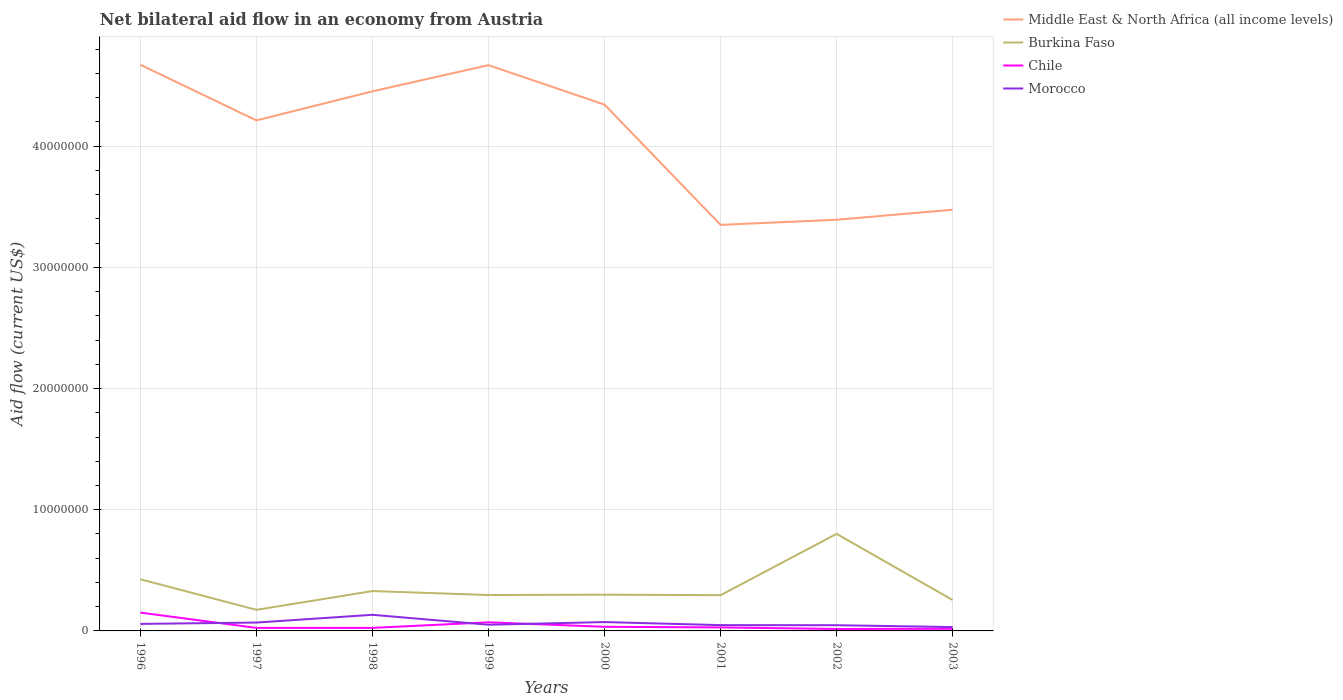Does the line corresponding to Middle East & North Africa (all income levels) intersect with the line corresponding to Chile?
Your answer should be compact. No. In which year was the net bilateral aid flow in Morocco maximum?
Your response must be concise. 2003. What is the difference between the highest and the second highest net bilateral aid flow in Middle East & North Africa (all income levels)?
Keep it short and to the point. 1.32e+07. What is the difference between the highest and the lowest net bilateral aid flow in Chile?
Keep it short and to the point. 2. How many lines are there?
Ensure brevity in your answer.  4. What is the difference between two consecutive major ticks on the Y-axis?
Provide a succinct answer. 1.00e+07. Where does the legend appear in the graph?
Keep it short and to the point. Top right. How many legend labels are there?
Keep it short and to the point. 4. How are the legend labels stacked?
Your answer should be compact. Vertical. What is the title of the graph?
Provide a succinct answer. Net bilateral aid flow in an economy from Austria. What is the Aid flow (current US$) of Middle East & North Africa (all income levels) in 1996?
Your response must be concise. 4.67e+07. What is the Aid flow (current US$) of Burkina Faso in 1996?
Keep it short and to the point. 4.26e+06. What is the Aid flow (current US$) in Chile in 1996?
Make the answer very short. 1.51e+06. What is the Aid flow (current US$) of Morocco in 1996?
Keep it short and to the point. 5.80e+05. What is the Aid flow (current US$) in Middle East & North Africa (all income levels) in 1997?
Provide a short and direct response. 4.21e+07. What is the Aid flow (current US$) in Burkina Faso in 1997?
Make the answer very short. 1.74e+06. What is the Aid flow (current US$) in Chile in 1997?
Offer a very short reply. 2.50e+05. What is the Aid flow (current US$) of Morocco in 1997?
Your response must be concise. 6.90e+05. What is the Aid flow (current US$) of Middle East & North Africa (all income levels) in 1998?
Provide a short and direct response. 4.45e+07. What is the Aid flow (current US$) of Burkina Faso in 1998?
Your answer should be very brief. 3.29e+06. What is the Aid flow (current US$) of Chile in 1998?
Your answer should be compact. 2.50e+05. What is the Aid flow (current US$) of Morocco in 1998?
Your response must be concise. 1.33e+06. What is the Aid flow (current US$) of Middle East & North Africa (all income levels) in 1999?
Keep it short and to the point. 4.67e+07. What is the Aid flow (current US$) of Burkina Faso in 1999?
Keep it short and to the point. 2.96e+06. What is the Aid flow (current US$) in Chile in 1999?
Keep it short and to the point. 7.10e+05. What is the Aid flow (current US$) in Morocco in 1999?
Your answer should be compact. 5.10e+05. What is the Aid flow (current US$) in Middle East & North Africa (all income levels) in 2000?
Provide a succinct answer. 4.34e+07. What is the Aid flow (current US$) in Burkina Faso in 2000?
Offer a terse response. 2.99e+06. What is the Aid flow (current US$) in Chile in 2000?
Provide a succinct answer. 3.40e+05. What is the Aid flow (current US$) in Morocco in 2000?
Offer a terse response. 7.30e+05. What is the Aid flow (current US$) of Middle East & North Africa (all income levels) in 2001?
Give a very brief answer. 3.35e+07. What is the Aid flow (current US$) in Burkina Faso in 2001?
Your response must be concise. 2.95e+06. What is the Aid flow (current US$) in Middle East & North Africa (all income levels) in 2002?
Your answer should be very brief. 3.39e+07. What is the Aid flow (current US$) in Burkina Faso in 2002?
Offer a terse response. 8.01e+06. What is the Aid flow (current US$) of Chile in 2002?
Ensure brevity in your answer.  1.60e+05. What is the Aid flow (current US$) in Morocco in 2002?
Keep it short and to the point. 4.70e+05. What is the Aid flow (current US$) of Middle East & North Africa (all income levels) in 2003?
Give a very brief answer. 3.48e+07. What is the Aid flow (current US$) in Burkina Faso in 2003?
Your answer should be compact. 2.55e+06. Across all years, what is the maximum Aid flow (current US$) in Middle East & North Africa (all income levels)?
Keep it short and to the point. 4.67e+07. Across all years, what is the maximum Aid flow (current US$) in Burkina Faso?
Your answer should be compact. 8.01e+06. Across all years, what is the maximum Aid flow (current US$) of Chile?
Provide a short and direct response. 1.51e+06. Across all years, what is the maximum Aid flow (current US$) in Morocco?
Offer a terse response. 1.33e+06. Across all years, what is the minimum Aid flow (current US$) of Middle East & North Africa (all income levels)?
Ensure brevity in your answer.  3.35e+07. Across all years, what is the minimum Aid flow (current US$) in Burkina Faso?
Your answer should be very brief. 1.74e+06. What is the total Aid flow (current US$) in Middle East & North Africa (all income levels) in the graph?
Your answer should be very brief. 3.26e+08. What is the total Aid flow (current US$) of Burkina Faso in the graph?
Your response must be concise. 2.88e+07. What is the total Aid flow (current US$) of Chile in the graph?
Offer a terse response. 3.69e+06. What is the total Aid flow (current US$) in Morocco in the graph?
Provide a short and direct response. 5.11e+06. What is the difference between the Aid flow (current US$) in Middle East & North Africa (all income levels) in 1996 and that in 1997?
Provide a succinct answer. 4.59e+06. What is the difference between the Aid flow (current US$) of Burkina Faso in 1996 and that in 1997?
Provide a short and direct response. 2.52e+06. What is the difference between the Aid flow (current US$) in Chile in 1996 and that in 1997?
Offer a terse response. 1.26e+06. What is the difference between the Aid flow (current US$) of Middle East & North Africa (all income levels) in 1996 and that in 1998?
Offer a very short reply. 2.19e+06. What is the difference between the Aid flow (current US$) of Burkina Faso in 1996 and that in 1998?
Offer a terse response. 9.70e+05. What is the difference between the Aid flow (current US$) of Chile in 1996 and that in 1998?
Your answer should be very brief. 1.26e+06. What is the difference between the Aid flow (current US$) in Morocco in 1996 and that in 1998?
Offer a terse response. -7.50e+05. What is the difference between the Aid flow (current US$) in Middle East & North Africa (all income levels) in 1996 and that in 1999?
Your answer should be compact. 3.00e+04. What is the difference between the Aid flow (current US$) of Burkina Faso in 1996 and that in 1999?
Make the answer very short. 1.30e+06. What is the difference between the Aid flow (current US$) in Middle East & North Africa (all income levels) in 1996 and that in 2000?
Your answer should be very brief. 3.29e+06. What is the difference between the Aid flow (current US$) of Burkina Faso in 1996 and that in 2000?
Your answer should be very brief. 1.27e+06. What is the difference between the Aid flow (current US$) in Chile in 1996 and that in 2000?
Provide a short and direct response. 1.17e+06. What is the difference between the Aid flow (current US$) in Middle East & North Africa (all income levels) in 1996 and that in 2001?
Offer a terse response. 1.32e+07. What is the difference between the Aid flow (current US$) of Burkina Faso in 1996 and that in 2001?
Offer a very short reply. 1.31e+06. What is the difference between the Aid flow (current US$) of Chile in 1996 and that in 2001?
Give a very brief answer. 1.22e+06. What is the difference between the Aid flow (current US$) in Middle East & North Africa (all income levels) in 1996 and that in 2002?
Your answer should be very brief. 1.28e+07. What is the difference between the Aid flow (current US$) in Burkina Faso in 1996 and that in 2002?
Keep it short and to the point. -3.75e+06. What is the difference between the Aid flow (current US$) of Chile in 1996 and that in 2002?
Give a very brief answer. 1.35e+06. What is the difference between the Aid flow (current US$) in Middle East & North Africa (all income levels) in 1996 and that in 2003?
Provide a short and direct response. 1.20e+07. What is the difference between the Aid flow (current US$) in Burkina Faso in 1996 and that in 2003?
Offer a terse response. 1.71e+06. What is the difference between the Aid flow (current US$) in Chile in 1996 and that in 2003?
Offer a terse response. 1.33e+06. What is the difference between the Aid flow (current US$) of Morocco in 1996 and that in 2003?
Offer a terse response. 2.60e+05. What is the difference between the Aid flow (current US$) in Middle East & North Africa (all income levels) in 1997 and that in 1998?
Keep it short and to the point. -2.40e+06. What is the difference between the Aid flow (current US$) in Burkina Faso in 1997 and that in 1998?
Ensure brevity in your answer.  -1.55e+06. What is the difference between the Aid flow (current US$) in Morocco in 1997 and that in 1998?
Keep it short and to the point. -6.40e+05. What is the difference between the Aid flow (current US$) in Middle East & North Africa (all income levels) in 1997 and that in 1999?
Provide a short and direct response. -4.56e+06. What is the difference between the Aid flow (current US$) of Burkina Faso in 1997 and that in 1999?
Your response must be concise. -1.22e+06. What is the difference between the Aid flow (current US$) in Chile in 1997 and that in 1999?
Your response must be concise. -4.60e+05. What is the difference between the Aid flow (current US$) of Morocco in 1997 and that in 1999?
Give a very brief answer. 1.80e+05. What is the difference between the Aid flow (current US$) of Middle East & North Africa (all income levels) in 1997 and that in 2000?
Give a very brief answer. -1.30e+06. What is the difference between the Aid flow (current US$) in Burkina Faso in 1997 and that in 2000?
Ensure brevity in your answer.  -1.25e+06. What is the difference between the Aid flow (current US$) in Middle East & North Africa (all income levels) in 1997 and that in 2001?
Ensure brevity in your answer.  8.62e+06. What is the difference between the Aid flow (current US$) in Burkina Faso in 1997 and that in 2001?
Make the answer very short. -1.21e+06. What is the difference between the Aid flow (current US$) of Middle East & North Africa (all income levels) in 1997 and that in 2002?
Keep it short and to the point. 8.20e+06. What is the difference between the Aid flow (current US$) in Burkina Faso in 1997 and that in 2002?
Provide a succinct answer. -6.27e+06. What is the difference between the Aid flow (current US$) of Morocco in 1997 and that in 2002?
Your response must be concise. 2.20e+05. What is the difference between the Aid flow (current US$) in Middle East & North Africa (all income levels) in 1997 and that in 2003?
Make the answer very short. 7.37e+06. What is the difference between the Aid flow (current US$) in Burkina Faso in 1997 and that in 2003?
Make the answer very short. -8.10e+05. What is the difference between the Aid flow (current US$) of Middle East & North Africa (all income levels) in 1998 and that in 1999?
Offer a very short reply. -2.16e+06. What is the difference between the Aid flow (current US$) of Chile in 1998 and that in 1999?
Provide a short and direct response. -4.60e+05. What is the difference between the Aid flow (current US$) of Morocco in 1998 and that in 1999?
Your answer should be very brief. 8.20e+05. What is the difference between the Aid flow (current US$) of Middle East & North Africa (all income levels) in 1998 and that in 2000?
Ensure brevity in your answer.  1.10e+06. What is the difference between the Aid flow (current US$) of Burkina Faso in 1998 and that in 2000?
Your answer should be compact. 3.00e+05. What is the difference between the Aid flow (current US$) in Morocco in 1998 and that in 2000?
Provide a short and direct response. 6.00e+05. What is the difference between the Aid flow (current US$) in Middle East & North Africa (all income levels) in 1998 and that in 2001?
Your answer should be very brief. 1.10e+07. What is the difference between the Aid flow (current US$) of Burkina Faso in 1998 and that in 2001?
Offer a terse response. 3.40e+05. What is the difference between the Aid flow (current US$) of Morocco in 1998 and that in 2001?
Offer a terse response. 8.50e+05. What is the difference between the Aid flow (current US$) of Middle East & North Africa (all income levels) in 1998 and that in 2002?
Offer a very short reply. 1.06e+07. What is the difference between the Aid flow (current US$) in Burkina Faso in 1998 and that in 2002?
Make the answer very short. -4.72e+06. What is the difference between the Aid flow (current US$) in Morocco in 1998 and that in 2002?
Make the answer very short. 8.60e+05. What is the difference between the Aid flow (current US$) in Middle East & North Africa (all income levels) in 1998 and that in 2003?
Make the answer very short. 9.77e+06. What is the difference between the Aid flow (current US$) in Burkina Faso in 1998 and that in 2003?
Provide a short and direct response. 7.40e+05. What is the difference between the Aid flow (current US$) of Chile in 1998 and that in 2003?
Make the answer very short. 7.00e+04. What is the difference between the Aid flow (current US$) in Morocco in 1998 and that in 2003?
Your answer should be very brief. 1.01e+06. What is the difference between the Aid flow (current US$) of Middle East & North Africa (all income levels) in 1999 and that in 2000?
Offer a terse response. 3.26e+06. What is the difference between the Aid flow (current US$) in Chile in 1999 and that in 2000?
Provide a short and direct response. 3.70e+05. What is the difference between the Aid flow (current US$) in Morocco in 1999 and that in 2000?
Provide a succinct answer. -2.20e+05. What is the difference between the Aid flow (current US$) in Middle East & North Africa (all income levels) in 1999 and that in 2001?
Offer a terse response. 1.32e+07. What is the difference between the Aid flow (current US$) in Morocco in 1999 and that in 2001?
Your response must be concise. 3.00e+04. What is the difference between the Aid flow (current US$) in Middle East & North Africa (all income levels) in 1999 and that in 2002?
Offer a very short reply. 1.28e+07. What is the difference between the Aid flow (current US$) in Burkina Faso in 1999 and that in 2002?
Provide a succinct answer. -5.05e+06. What is the difference between the Aid flow (current US$) of Chile in 1999 and that in 2002?
Make the answer very short. 5.50e+05. What is the difference between the Aid flow (current US$) of Morocco in 1999 and that in 2002?
Ensure brevity in your answer.  4.00e+04. What is the difference between the Aid flow (current US$) in Middle East & North Africa (all income levels) in 1999 and that in 2003?
Offer a very short reply. 1.19e+07. What is the difference between the Aid flow (current US$) of Burkina Faso in 1999 and that in 2003?
Make the answer very short. 4.10e+05. What is the difference between the Aid flow (current US$) in Chile in 1999 and that in 2003?
Your answer should be compact. 5.30e+05. What is the difference between the Aid flow (current US$) of Middle East & North Africa (all income levels) in 2000 and that in 2001?
Offer a terse response. 9.92e+06. What is the difference between the Aid flow (current US$) in Chile in 2000 and that in 2001?
Make the answer very short. 5.00e+04. What is the difference between the Aid flow (current US$) of Middle East & North Africa (all income levels) in 2000 and that in 2002?
Your answer should be compact. 9.50e+06. What is the difference between the Aid flow (current US$) in Burkina Faso in 2000 and that in 2002?
Offer a terse response. -5.02e+06. What is the difference between the Aid flow (current US$) of Middle East & North Africa (all income levels) in 2000 and that in 2003?
Your answer should be very brief. 8.67e+06. What is the difference between the Aid flow (current US$) of Burkina Faso in 2000 and that in 2003?
Make the answer very short. 4.40e+05. What is the difference between the Aid flow (current US$) of Chile in 2000 and that in 2003?
Make the answer very short. 1.60e+05. What is the difference between the Aid flow (current US$) in Morocco in 2000 and that in 2003?
Provide a short and direct response. 4.10e+05. What is the difference between the Aid flow (current US$) of Middle East & North Africa (all income levels) in 2001 and that in 2002?
Your answer should be compact. -4.20e+05. What is the difference between the Aid flow (current US$) of Burkina Faso in 2001 and that in 2002?
Your answer should be very brief. -5.06e+06. What is the difference between the Aid flow (current US$) in Chile in 2001 and that in 2002?
Offer a terse response. 1.30e+05. What is the difference between the Aid flow (current US$) in Middle East & North Africa (all income levels) in 2001 and that in 2003?
Ensure brevity in your answer.  -1.25e+06. What is the difference between the Aid flow (current US$) of Morocco in 2001 and that in 2003?
Make the answer very short. 1.60e+05. What is the difference between the Aid flow (current US$) of Middle East & North Africa (all income levels) in 2002 and that in 2003?
Make the answer very short. -8.30e+05. What is the difference between the Aid flow (current US$) in Burkina Faso in 2002 and that in 2003?
Offer a terse response. 5.46e+06. What is the difference between the Aid flow (current US$) of Chile in 2002 and that in 2003?
Offer a very short reply. -2.00e+04. What is the difference between the Aid flow (current US$) of Morocco in 2002 and that in 2003?
Ensure brevity in your answer.  1.50e+05. What is the difference between the Aid flow (current US$) in Middle East & North Africa (all income levels) in 1996 and the Aid flow (current US$) in Burkina Faso in 1997?
Give a very brief answer. 4.50e+07. What is the difference between the Aid flow (current US$) of Middle East & North Africa (all income levels) in 1996 and the Aid flow (current US$) of Chile in 1997?
Offer a terse response. 4.65e+07. What is the difference between the Aid flow (current US$) of Middle East & North Africa (all income levels) in 1996 and the Aid flow (current US$) of Morocco in 1997?
Offer a terse response. 4.60e+07. What is the difference between the Aid flow (current US$) in Burkina Faso in 1996 and the Aid flow (current US$) in Chile in 1997?
Keep it short and to the point. 4.01e+06. What is the difference between the Aid flow (current US$) of Burkina Faso in 1996 and the Aid flow (current US$) of Morocco in 1997?
Your answer should be very brief. 3.57e+06. What is the difference between the Aid flow (current US$) of Chile in 1996 and the Aid flow (current US$) of Morocco in 1997?
Your answer should be compact. 8.20e+05. What is the difference between the Aid flow (current US$) in Middle East & North Africa (all income levels) in 1996 and the Aid flow (current US$) in Burkina Faso in 1998?
Keep it short and to the point. 4.34e+07. What is the difference between the Aid flow (current US$) of Middle East & North Africa (all income levels) in 1996 and the Aid flow (current US$) of Chile in 1998?
Your answer should be compact. 4.65e+07. What is the difference between the Aid flow (current US$) in Middle East & North Africa (all income levels) in 1996 and the Aid flow (current US$) in Morocco in 1998?
Offer a very short reply. 4.54e+07. What is the difference between the Aid flow (current US$) of Burkina Faso in 1996 and the Aid flow (current US$) of Chile in 1998?
Offer a very short reply. 4.01e+06. What is the difference between the Aid flow (current US$) in Burkina Faso in 1996 and the Aid flow (current US$) in Morocco in 1998?
Your response must be concise. 2.93e+06. What is the difference between the Aid flow (current US$) in Chile in 1996 and the Aid flow (current US$) in Morocco in 1998?
Provide a short and direct response. 1.80e+05. What is the difference between the Aid flow (current US$) in Middle East & North Africa (all income levels) in 1996 and the Aid flow (current US$) in Burkina Faso in 1999?
Offer a terse response. 4.38e+07. What is the difference between the Aid flow (current US$) of Middle East & North Africa (all income levels) in 1996 and the Aid flow (current US$) of Chile in 1999?
Offer a very short reply. 4.60e+07. What is the difference between the Aid flow (current US$) in Middle East & North Africa (all income levels) in 1996 and the Aid flow (current US$) in Morocco in 1999?
Keep it short and to the point. 4.62e+07. What is the difference between the Aid flow (current US$) in Burkina Faso in 1996 and the Aid flow (current US$) in Chile in 1999?
Provide a succinct answer. 3.55e+06. What is the difference between the Aid flow (current US$) in Burkina Faso in 1996 and the Aid flow (current US$) in Morocco in 1999?
Your answer should be compact. 3.75e+06. What is the difference between the Aid flow (current US$) of Chile in 1996 and the Aid flow (current US$) of Morocco in 1999?
Your response must be concise. 1.00e+06. What is the difference between the Aid flow (current US$) in Middle East & North Africa (all income levels) in 1996 and the Aid flow (current US$) in Burkina Faso in 2000?
Make the answer very short. 4.37e+07. What is the difference between the Aid flow (current US$) in Middle East & North Africa (all income levels) in 1996 and the Aid flow (current US$) in Chile in 2000?
Your answer should be compact. 4.64e+07. What is the difference between the Aid flow (current US$) of Middle East & North Africa (all income levels) in 1996 and the Aid flow (current US$) of Morocco in 2000?
Your answer should be compact. 4.60e+07. What is the difference between the Aid flow (current US$) of Burkina Faso in 1996 and the Aid flow (current US$) of Chile in 2000?
Ensure brevity in your answer.  3.92e+06. What is the difference between the Aid flow (current US$) in Burkina Faso in 1996 and the Aid flow (current US$) in Morocco in 2000?
Ensure brevity in your answer.  3.53e+06. What is the difference between the Aid flow (current US$) of Chile in 1996 and the Aid flow (current US$) of Morocco in 2000?
Provide a succinct answer. 7.80e+05. What is the difference between the Aid flow (current US$) in Middle East & North Africa (all income levels) in 1996 and the Aid flow (current US$) in Burkina Faso in 2001?
Your answer should be very brief. 4.38e+07. What is the difference between the Aid flow (current US$) of Middle East & North Africa (all income levels) in 1996 and the Aid flow (current US$) of Chile in 2001?
Ensure brevity in your answer.  4.64e+07. What is the difference between the Aid flow (current US$) of Middle East & North Africa (all income levels) in 1996 and the Aid flow (current US$) of Morocco in 2001?
Provide a short and direct response. 4.62e+07. What is the difference between the Aid flow (current US$) in Burkina Faso in 1996 and the Aid flow (current US$) in Chile in 2001?
Keep it short and to the point. 3.97e+06. What is the difference between the Aid flow (current US$) of Burkina Faso in 1996 and the Aid flow (current US$) of Morocco in 2001?
Your response must be concise. 3.78e+06. What is the difference between the Aid flow (current US$) of Chile in 1996 and the Aid flow (current US$) of Morocco in 2001?
Provide a short and direct response. 1.03e+06. What is the difference between the Aid flow (current US$) of Middle East & North Africa (all income levels) in 1996 and the Aid flow (current US$) of Burkina Faso in 2002?
Ensure brevity in your answer.  3.87e+07. What is the difference between the Aid flow (current US$) in Middle East & North Africa (all income levels) in 1996 and the Aid flow (current US$) in Chile in 2002?
Make the answer very short. 4.66e+07. What is the difference between the Aid flow (current US$) of Middle East & North Africa (all income levels) in 1996 and the Aid flow (current US$) of Morocco in 2002?
Your answer should be compact. 4.62e+07. What is the difference between the Aid flow (current US$) of Burkina Faso in 1996 and the Aid flow (current US$) of Chile in 2002?
Provide a short and direct response. 4.10e+06. What is the difference between the Aid flow (current US$) of Burkina Faso in 1996 and the Aid flow (current US$) of Morocco in 2002?
Your answer should be very brief. 3.79e+06. What is the difference between the Aid flow (current US$) of Chile in 1996 and the Aid flow (current US$) of Morocco in 2002?
Your answer should be compact. 1.04e+06. What is the difference between the Aid flow (current US$) of Middle East & North Africa (all income levels) in 1996 and the Aid flow (current US$) of Burkina Faso in 2003?
Offer a very short reply. 4.42e+07. What is the difference between the Aid flow (current US$) of Middle East & North Africa (all income levels) in 1996 and the Aid flow (current US$) of Chile in 2003?
Offer a terse response. 4.65e+07. What is the difference between the Aid flow (current US$) in Middle East & North Africa (all income levels) in 1996 and the Aid flow (current US$) in Morocco in 2003?
Provide a succinct answer. 4.64e+07. What is the difference between the Aid flow (current US$) in Burkina Faso in 1996 and the Aid flow (current US$) in Chile in 2003?
Make the answer very short. 4.08e+06. What is the difference between the Aid flow (current US$) of Burkina Faso in 1996 and the Aid flow (current US$) of Morocco in 2003?
Provide a short and direct response. 3.94e+06. What is the difference between the Aid flow (current US$) of Chile in 1996 and the Aid flow (current US$) of Morocco in 2003?
Offer a terse response. 1.19e+06. What is the difference between the Aid flow (current US$) in Middle East & North Africa (all income levels) in 1997 and the Aid flow (current US$) in Burkina Faso in 1998?
Keep it short and to the point. 3.88e+07. What is the difference between the Aid flow (current US$) of Middle East & North Africa (all income levels) in 1997 and the Aid flow (current US$) of Chile in 1998?
Provide a short and direct response. 4.19e+07. What is the difference between the Aid flow (current US$) of Middle East & North Africa (all income levels) in 1997 and the Aid flow (current US$) of Morocco in 1998?
Your answer should be compact. 4.08e+07. What is the difference between the Aid flow (current US$) of Burkina Faso in 1997 and the Aid flow (current US$) of Chile in 1998?
Offer a very short reply. 1.49e+06. What is the difference between the Aid flow (current US$) of Burkina Faso in 1997 and the Aid flow (current US$) of Morocco in 1998?
Make the answer very short. 4.10e+05. What is the difference between the Aid flow (current US$) in Chile in 1997 and the Aid flow (current US$) in Morocco in 1998?
Offer a terse response. -1.08e+06. What is the difference between the Aid flow (current US$) of Middle East & North Africa (all income levels) in 1997 and the Aid flow (current US$) of Burkina Faso in 1999?
Make the answer very short. 3.92e+07. What is the difference between the Aid flow (current US$) of Middle East & North Africa (all income levels) in 1997 and the Aid flow (current US$) of Chile in 1999?
Provide a short and direct response. 4.14e+07. What is the difference between the Aid flow (current US$) of Middle East & North Africa (all income levels) in 1997 and the Aid flow (current US$) of Morocco in 1999?
Offer a very short reply. 4.16e+07. What is the difference between the Aid flow (current US$) of Burkina Faso in 1997 and the Aid flow (current US$) of Chile in 1999?
Provide a short and direct response. 1.03e+06. What is the difference between the Aid flow (current US$) of Burkina Faso in 1997 and the Aid flow (current US$) of Morocco in 1999?
Provide a succinct answer. 1.23e+06. What is the difference between the Aid flow (current US$) of Chile in 1997 and the Aid flow (current US$) of Morocco in 1999?
Provide a succinct answer. -2.60e+05. What is the difference between the Aid flow (current US$) of Middle East & North Africa (all income levels) in 1997 and the Aid flow (current US$) of Burkina Faso in 2000?
Your answer should be compact. 3.91e+07. What is the difference between the Aid flow (current US$) in Middle East & North Africa (all income levels) in 1997 and the Aid flow (current US$) in Chile in 2000?
Provide a succinct answer. 4.18e+07. What is the difference between the Aid flow (current US$) of Middle East & North Africa (all income levels) in 1997 and the Aid flow (current US$) of Morocco in 2000?
Provide a succinct answer. 4.14e+07. What is the difference between the Aid flow (current US$) of Burkina Faso in 1997 and the Aid flow (current US$) of Chile in 2000?
Provide a succinct answer. 1.40e+06. What is the difference between the Aid flow (current US$) in Burkina Faso in 1997 and the Aid flow (current US$) in Morocco in 2000?
Your answer should be compact. 1.01e+06. What is the difference between the Aid flow (current US$) of Chile in 1997 and the Aid flow (current US$) of Morocco in 2000?
Your response must be concise. -4.80e+05. What is the difference between the Aid flow (current US$) in Middle East & North Africa (all income levels) in 1997 and the Aid flow (current US$) in Burkina Faso in 2001?
Your answer should be very brief. 3.92e+07. What is the difference between the Aid flow (current US$) of Middle East & North Africa (all income levels) in 1997 and the Aid flow (current US$) of Chile in 2001?
Your answer should be very brief. 4.18e+07. What is the difference between the Aid flow (current US$) of Middle East & North Africa (all income levels) in 1997 and the Aid flow (current US$) of Morocco in 2001?
Offer a terse response. 4.16e+07. What is the difference between the Aid flow (current US$) of Burkina Faso in 1997 and the Aid flow (current US$) of Chile in 2001?
Make the answer very short. 1.45e+06. What is the difference between the Aid flow (current US$) of Burkina Faso in 1997 and the Aid flow (current US$) of Morocco in 2001?
Offer a terse response. 1.26e+06. What is the difference between the Aid flow (current US$) of Middle East & North Africa (all income levels) in 1997 and the Aid flow (current US$) of Burkina Faso in 2002?
Provide a short and direct response. 3.41e+07. What is the difference between the Aid flow (current US$) in Middle East & North Africa (all income levels) in 1997 and the Aid flow (current US$) in Chile in 2002?
Your answer should be compact. 4.20e+07. What is the difference between the Aid flow (current US$) in Middle East & North Africa (all income levels) in 1997 and the Aid flow (current US$) in Morocco in 2002?
Offer a terse response. 4.17e+07. What is the difference between the Aid flow (current US$) in Burkina Faso in 1997 and the Aid flow (current US$) in Chile in 2002?
Your answer should be very brief. 1.58e+06. What is the difference between the Aid flow (current US$) of Burkina Faso in 1997 and the Aid flow (current US$) of Morocco in 2002?
Offer a very short reply. 1.27e+06. What is the difference between the Aid flow (current US$) in Chile in 1997 and the Aid flow (current US$) in Morocco in 2002?
Provide a short and direct response. -2.20e+05. What is the difference between the Aid flow (current US$) of Middle East & North Africa (all income levels) in 1997 and the Aid flow (current US$) of Burkina Faso in 2003?
Ensure brevity in your answer.  3.96e+07. What is the difference between the Aid flow (current US$) of Middle East & North Africa (all income levels) in 1997 and the Aid flow (current US$) of Chile in 2003?
Keep it short and to the point. 4.20e+07. What is the difference between the Aid flow (current US$) of Middle East & North Africa (all income levels) in 1997 and the Aid flow (current US$) of Morocco in 2003?
Keep it short and to the point. 4.18e+07. What is the difference between the Aid flow (current US$) of Burkina Faso in 1997 and the Aid flow (current US$) of Chile in 2003?
Offer a terse response. 1.56e+06. What is the difference between the Aid flow (current US$) of Burkina Faso in 1997 and the Aid flow (current US$) of Morocco in 2003?
Keep it short and to the point. 1.42e+06. What is the difference between the Aid flow (current US$) in Chile in 1997 and the Aid flow (current US$) in Morocco in 2003?
Offer a very short reply. -7.00e+04. What is the difference between the Aid flow (current US$) of Middle East & North Africa (all income levels) in 1998 and the Aid flow (current US$) of Burkina Faso in 1999?
Offer a terse response. 4.16e+07. What is the difference between the Aid flow (current US$) in Middle East & North Africa (all income levels) in 1998 and the Aid flow (current US$) in Chile in 1999?
Your answer should be compact. 4.38e+07. What is the difference between the Aid flow (current US$) in Middle East & North Africa (all income levels) in 1998 and the Aid flow (current US$) in Morocco in 1999?
Offer a terse response. 4.40e+07. What is the difference between the Aid flow (current US$) in Burkina Faso in 1998 and the Aid flow (current US$) in Chile in 1999?
Your answer should be very brief. 2.58e+06. What is the difference between the Aid flow (current US$) of Burkina Faso in 1998 and the Aid flow (current US$) of Morocco in 1999?
Offer a terse response. 2.78e+06. What is the difference between the Aid flow (current US$) in Chile in 1998 and the Aid flow (current US$) in Morocco in 1999?
Offer a very short reply. -2.60e+05. What is the difference between the Aid flow (current US$) in Middle East & North Africa (all income levels) in 1998 and the Aid flow (current US$) in Burkina Faso in 2000?
Your answer should be very brief. 4.15e+07. What is the difference between the Aid flow (current US$) of Middle East & North Africa (all income levels) in 1998 and the Aid flow (current US$) of Chile in 2000?
Your answer should be very brief. 4.42e+07. What is the difference between the Aid flow (current US$) of Middle East & North Africa (all income levels) in 1998 and the Aid flow (current US$) of Morocco in 2000?
Provide a succinct answer. 4.38e+07. What is the difference between the Aid flow (current US$) of Burkina Faso in 1998 and the Aid flow (current US$) of Chile in 2000?
Ensure brevity in your answer.  2.95e+06. What is the difference between the Aid flow (current US$) of Burkina Faso in 1998 and the Aid flow (current US$) of Morocco in 2000?
Keep it short and to the point. 2.56e+06. What is the difference between the Aid flow (current US$) of Chile in 1998 and the Aid flow (current US$) of Morocco in 2000?
Your response must be concise. -4.80e+05. What is the difference between the Aid flow (current US$) of Middle East & North Africa (all income levels) in 1998 and the Aid flow (current US$) of Burkina Faso in 2001?
Offer a very short reply. 4.16e+07. What is the difference between the Aid flow (current US$) of Middle East & North Africa (all income levels) in 1998 and the Aid flow (current US$) of Chile in 2001?
Your answer should be very brief. 4.42e+07. What is the difference between the Aid flow (current US$) of Middle East & North Africa (all income levels) in 1998 and the Aid flow (current US$) of Morocco in 2001?
Ensure brevity in your answer.  4.40e+07. What is the difference between the Aid flow (current US$) of Burkina Faso in 1998 and the Aid flow (current US$) of Morocco in 2001?
Keep it short and to the point. 2.81e+06. What is the difference between the Aid flow (current US$) of Middle East & North Africa (all income levels) in 1998 and the Aid flow (current US$) of Burkina Faso in 2002?
Make the answer very short. 3.65e+07. What is the difference between the Aid flow (current US$) in Middle East & North Africa (all income levels) in 1998 and the Aid flow (current US$) in Chile in 2002?
Ensure brevity in your answer.  4.44e+07. What is the difference between the Aid flow (current US$) of Middle East & North Africa (all income levels) in 1998 and the Aid flow (current US$) of Morocco in 2002?
Offer a terse response. 4.41e+07. What is the difference between the Aid flow (current US$) of Burkina Faso in 1998 and the Aid flow (current US$) of Chile in 2002?
Provide a short and direct response. 3.13e+06. What is the difference between the Aid flow (current US$) in Burkina Faso in 1998 and the Aid flow (current US$) in Morocco in 2002?
Provide a short and direct response. 2.82e+06. What is the difference between the Aid flow (current US$) of Middle East & North Africa (all income levels) in 1998 and the Aid flow (current US$) of Burkina Faso in 2003?
Make the answer very short. 4.20e+07. What is the difference between the Aid flow (current US$) in Middle East & North Africa (all income levels) in 1998 and the Aid flow (current US$) in Chile in 2003?
Ensure brevity in your answer.  4.44e+07. What is the difference between the Aid flow (current US$) of Middle East & North Africa (all income levels) in 1998 and the Aid flow (current US$) of Morocco in 2003?
Make the answer very short. 4.42e+07. What is the difference between the Aid flow (current US$) of Burkina Faso in 1998 and the Aid flow (current US$) of Chile in 2003?
Your response must be concise. 3.11e+06. What is the difference between the Aid flow (current US$) in Burkina Faso in 1998 and the Aid flow (current US$) in Morocco in 2003?
Provide a succinct answer. 2.97e+06. What is the difference between the Aid flow (current US$) in Middle East & North Africa (all income levels) in 1999 and the Aid flow (current US$) in Burkina Faso in 2000?
Keep it short and to the point. 4.37e+07. What is the difference between the Aid flow (current US$) of Middle East & North Africa (all income levels) in 1999 and the Aid flow (current US$) of Chile in 2000?
Your response must be concise. 4.64e+07. What is the difference between the Aid flow (current US$) in Middle East & North Africa (all income levels) in 1999 and the Aid flow (current US$) in Morocco in 2000?
Provide a succinct answer. 4.60e+07. What is the difference between the Aid flow (current US$) of Burkina Faso in 1999 and the Aid flow (current US$) of Chile in 2000?
Your response must be concise. 2.62e+06. What is the difference between the Aid flow (current US$) in Burkina Faso in 1999 and the Aid flow (current US$) in Morocco in 2000?
Ensure brevity in your answer.  2.23e+06. What is the difference between the Aid flow (current US$) of Chile in 1999 and the Aid flow (current US$) of Morocco in 2000?
Provide a short and direct response. -2.00e+04. What is the difference between the Aid flow (current US$) of Middle East & North Africa (all income levels) in 1999 and the Aid flow (current US$) of Burkina Faso in 2001?
Your response must be concise. 4.37e+07. What is the difference between the Aid flow (current US$) in Middle East & North Africa (all income levels) in 1999 and the Aid flow (current US$) in Chile in 2001?
Ensure brevity in your answer.  4.64e+07. What is the difference between the Aid flow (current US$) of Middle East & North Africa (all income levels) in 1999 and the Aid flow (current US$) of Morocco in 2001?
Provide a succinct answer. 4.62e+07. What is the difference between the Aid flow (current US$) of Burkina Faso in 1999 and the Aid flow (current US$) of Chile in 2001?
Make the answer very short. 2.67e+06. What is the difference between the Aid flow (current US$) of Burkina Faso in 1999 and the Aid flow (current US$) of Morocco in 2001?
Keep it short and to the point. 2.48e+06. What is the difference between the Aid flow (current US$) of Middle East & North Africa (all income levels) in 1999 and the Aid flow (current US$) of Burkina Faso in 2002?
Ensure brevity in your answer.  3.87e+07. What is the difference between the Aid flow (current US$) of Middle East & North Africa (all income levels) in 1999 and the Aid flow (current US$) of Chile in 2002?
Keep it short and to the point. 4.65e+07. What is the difference between the Aid flow (current US$) of Middle East & North Africa (all income levels) in 1999 and the Aid flow (current US$) of Morocco in 2002?
Your answer should be compact. 4.62e+07. What is the difference between the Aid flow (current US$) in Burkina Faso in 1999 and the Aid flow (current US$) in Chile in 2002?
Your response must be concise. 2.80e+06. What is the difference between the Aid flow (current US$) in Burkina Faso in 1999 and the Aid flow (current US$) in Morocco in 2002?
Provide a succinct answer. 2.49e+06. What is the difference between the Aid flow (current US$) in Chile in 1999 and the Aid flow (current US$) in Morocco in 2002?
Your response must be concise. 2.40e+05. What is the difference between the Aid flow (current US$) of Middle East & North Africa (all income levels) in 1999 and the Aid flow (current US$) of Burkina Faso in 2003?
Your answer should be compact. 4.41e+07. What is the difference between the Aid flow (current US$) of Middle East & North Africa (all income levels) in 1999 and the Aid flow (current US$) of Chile in 2003?
Your answer should be very brief. 4.65e+07. What is the difference between the Aid flow (current US$) in Middle East & North Africa (all income levels) in 1999 and the Aid flow (current US$) in Morocco in 2003?
Provide a succinct answer. 4.64e+07. What is the difference between the Aid flow (current US$) in Burkina Faso in 1999 and the Aid flow (current US$) in Chile in 2003?
Keep it short and to the point. 2.78e+06. What is the difference between the Aid flow (current US$) in Burkina Faso in 1999 and the Aid flow (current US$) in Morocco in 2003?
Keep it short and to the point. 2.64e+06. What is the difference between the Aid flow (current US$) of Middle East & North Africa (all income levels) in 2000 and the Aid flow (current US$) of Burkina Faso in 2001?
Your response must be concise. 4.05e+07. What is the difference between the Aid flow (current US$) in Middle East & North Africa (all income levels) in 2000 and the Aid flow (current US$) in Chile in 2001?
Your answer should be very brief. 4.31e+07. What is the difference between the Aid flow (current US$) in Middle East & North Africa (all income levels) in 2000 and the Aid flow (current US$) in Morocco in 2001?
Your response must be concise. 4.30e+07. What is the difference between the Aid flow (current US$) of Burkina Faso in 2000 and the Aid flow (current US$) of Chile in 2001?
Keep it short and to the point. 2.70e+06. What is the difference between the Aid flow (current US$) in Burkina Faso in 2000 and the Aid flow (current US$) in Morocco in 2001?
Your answer should be compact. 2.51e+06. What is the difference between the Aid flow (current US$) in Chile in 2000 and the Aid flow (current US$) in Morocco in 2001?
Provide a succinct answer. -1.40e+05. What is the difference between the Aid flow (current US$) in Middle East & North Africa (all income levels) in 2000 and the Aid flow (current US$) in Burkina Faso in 2002?
Your answer should be very brief. 3.54e+07. What is the difference between the Aid flow (current US$) of Middle East & North Africa (all income levels) in 2000 and the Aid flow (current US$) of Chile in 2002?
Offer a terse response. 4.33e+07. What is the difference between the Aid flow (current US$) of Middle East & North Africa (all income levels) in 2000 and the Aid flow (current US$) of Morocco in 2002?
Your answer should be very brief. 4.30e+07. What is the difference between the Aid flow (current US$) in Burkina Faso in 2000 and the Aid flow (current US$) in Chile in 2002?
Give a very brief answer. 2.83e+06. What is the difference between the Aid flow (current US$) of Burkina Faso in 2000 and the Aid flow (current US$) of Morocco in 2002?
Provide a succinct answer. 2.52e+06. What is the difference between the Aid flow (current US$) of Middle East & North Africa (all income levels) in 2000 and the Aid flow (current US$) of Burkina Faso in 2003?
Keep it short and to the point. 4.09e+07. What is the difference between the Aid flow (current US$) in Middle East & North Africa (all income levels) in 2000 and the Aid flow (current US$) in Chile in 2003?
Keep it short and to the point. 4.32e+07. What is the difference between the Aid flow (current US$) of Middle East & North Africa (all income levels) in 2000 and the Aid flow (current US$) of Morocco in 2003?
Offer a terse response. 4.31e+07. What is the difference between the Aid flow (current US$) in Burkina Faso in 2000 and the Aid flow (current US$) in Chile in 2003?
Provide a succinct answer. 2.81e+06. What is the difference between the Aid flow (current US$) of Burkina Faso in 2000 and the Aid flow (current US$) of Morocco in 2003?
Offer a very short reply. 2.67e+06. What is the difference between the Aid flow (current US$) in Chile in 2000 and the Aid flow (current US$) in Morocco in 2003?
Your answer should be compact. 2.00e+04. What is the difference between the Aid flow (current US$) in Middle East & North Africa (all income levels) in 2001 and the Aid flow (current US$) in Burkina Faso in 2002?
Provide a succinct answer. 2.55e+07. What is the difference between the Aid flow (current US$) in Middle East & North Africa (all income levels) in 2001 and the Aid flow (current US$) in Chile in 2002?
Make the answer very short. 3.34e+07. What is the difference between the Aid flow (current US$) in Middle East & North Africa (all income levels) in 2001 and the Aid flow (current US$) in Morocco in 2002?
Offer a very short reply. 3.30e+07. What is the difference between the Aid flow (current US$) of Burkina Faso in 2001 and the Aid flow (current US$) of Chile in 2002?
Your response must be concise. 2.79e+06. What is the difference between the Aid flow (current US$) in Burkina Faso in 2001 and the Aid flow (current US$) in Morocco in 2002?
Offer a very short reply. 2.48e+06. What is the difference between the Aid flow (current US$) in Chile in 2001 and the Aid flow (current US$) in Morocco in 2002?
Provide a succinct answer. -1.80e+05. What is the difference between the Aid flow (current US$) of Middle East & North Africa (all income levels) in 2001 and the Aid flow (current US$) of Burkina Faso in 2003?
Your response must be concise. 3.10e+07. What is the difference between the Aid flow (current US$) of Middle East & North Africa (all income levels) in 2001 and the Aid flow (current US$) of Chile in 2003?
Offer a terse response. 3.33e+07. What is the difference between the Aid flow (current US$) of Middle East & North Africa (all income levels) in 2001 and the Aid flow (current US$) of Morocco in 2003?
Your response must be concise. 3.32e+07. What is the difference between the Aid flow (current US$) in Burkina Faso in 2001 and the Aid flow (current US$) in Chile in 2003?
Provide a succinct answer. 2.77e+06. What is the difference between the Aid flow (current US$) in Burkina Faso in 2001 and the Aid flow (current US$) in Morocco in 2003?
Offer a terse response. 2.63e+06. What is the difference between the Aid flow (current US$) in Chile in 2001 and the Aid flow (current US$) in Morocco in 2003?
Make the answer very short. -3.00e+04. What is the difference between the Aid flow (current US$) of Middle East & North Africa (all income levels) in 2002 and the Aid flow (current US$) of Burkina Faso in 2003?
Make the answer very short. 3.14e+07. What is the difference between the Aid flow (current US$) of Middle East & North Africa (all income levels) in 2002 and the Aid flow (current US$) of Chile in 2003?
Your answer should be compact. 3.38e+07. What is the difference between the Aid flow (current US$) in Middle East & North Africa (all income levels) in 2002 and the Aid flow (current US$) in Morocco in 2003?
Keep it short and to the point. 3.36e+07. What is the difference between the Aid flow (current US$) of Burkina Faso in 2002 and the Aid flow (current US$) of Chile in 2003?
Your response must be concise. 7.83e+06. What is the difference between the Aid flow (current US$) in Burkina Faso in 2002 and the Aid flow (current US$) in Morocco in 2003?
Keep it short and to the point. 7.69e+06. What is the difference between the Aid flow (current US$) in Chile in 2002 and the Aid flow (current US$) in Morocco in 2003?
Provide a succinct answer. -1.60e+05. What is the average Aid flow (current US$) in Middle East & North Africa (all income levels) per year?
Keep it short and to the point. 4.07e+07. What is the average Aid flow (current US$) in Burkina Faso per year?
Offer a terse response. 3.59e+06. What is the average Aid flow (current US$) of Chile per year?
Provide a succinct answer. 4.61e+05. What is the average Aid flow (current US$) of Morocco per year?
Offer a terse response. 6.39e+05. In the year 1996, what is the difference between the Aid flow (current US$) in Middle East & North Africa (all income levels) and Aid flow (current US$) in Burkina Faso?
Offer a terse response. 4.25e+07. In the year 1996, what is the difference between the Aid flow (current US$) of Middle East & North Africa (all income levels) and Aid flow (current US$) of Chile?
Offer a terse response. 4.52e+07. In the year 1996, what is the difference between the Aid flow (current US$) of Middle East & North Africa (all income levels) and Aid flow (current US$) of Morocco?
Offer a terse response. 4.61e+07. In the year 1996, what is the difference between the Aid flow (current US$) of Burkina Faso and Aid flow (current US$) of Chile?
Provide a short and direct response. 2.75e+06. In the year 1996, what is the difference between the Aid flow (current US$) of Burkina Faso and Aid flow (current US$) of Morocco?
Your answer should be compact. 3.68e+06. In the year 1996, what is the difference between the Aid flow (current US$) of Chile and Aid flow (current US$) of Morocco?
Provide a succinct answer. 9.30e+05. In the year 1997, what is the difference between the Aid flow (current US$) in Middle East & North Africa (all income levels) and Aid flow (current US$) in Burkina Faso?
Provide a succinct answer. 4.04e+07. In the year 1997, what is the difference between the Aid flow (current US$) of Middle East & North Africa (all income levels) and Aid flow (current US$) of Chile?
Ensure brevity in your answer.  4.19e+07. In the year 1997, what is the difference between the Aid flow (current US$) of Middle East & North Africa (all income levels) and Aid flow (current US$) of Morocco?
Make the answer very short. 4.14e+07. In the year 1997, what is the difference between the Aid flow (current US$) of Burkina Faso and Aid flow (current US$) of Chile?
Give a very brief answer. 1.49e+06. In the year 1997, what is the difference between the Aid flow (current US$) of Burkina Faso and Aid flow (current US$) of Morocco?
Ensure brevity in your answer.  1.05e+06. In the year 1997, what is the difference between the Aid flow (current US$) of Chile and Aid flow (current US$) of Morocco?
Your answer should be compact. -4.40e+05. In the year 1998, what is the difference between the Aid flow (current US$) of Middle East & North Africa (all income levels) and Aid flow (current US$) of Burkina Faso?
Your answer should be compact. 4.12e+07. In the year 1998, what is the difference between the Aid flow (current US$) in Middle East & North Africa (all income levels) and Aid flow (current US$) in Chile?
Ensure brevity in your answer.  4.43e+07. In the year 1998, what is the difference between the Aid flow (current US$) of Middle East & North Africa (all income levels) and Aid flow (current US$) of Morocco?
Offer a terse response. 4.32e+07. In the year 1998, what is the difference between the Aid flow (current US$) in Burkina Faso and Aid flow (current US$) in Chile?
Give a very brief answer. 3.04e+06. In the year 1998, what is the difference between the Aid flow (current US$) of Burkina Faso and Aid flow (current US$) of Morocco?
Ensure brevity in your answer.  1.96e+06. In the year 1998, what is the difference between the Aid flow (current US$) in Chile and Aid flow (current US$) in Morocco?
Make the answer very short. -1.08e+06. In the year 1999, what is the difference between the Aid flow (current US$) in Middle East & North Africa (all income levels) and Aid flow (current US$) in Burkina Faso?
Make the answer very short. 4.37e+07. In the year 1999, what is the difference between the Aid flow (current US$) of Middle East & North Africa (all income levels) and Aid flow (current US$) of Chile?
Offer a terse response. 4.60e+07. In the year 1999, what is the difference between the Aid flow (current US$) of Middle East & North Africa (all income levels) and Aid flow (current US$) of Morocco?
Ensure brevity in your answer.  4.62e+07. In the year 1999, what is the difference between the Aid flow (current US$) in Burkina Faso and Aid flow (current US$) in Chile?
Offer a very short reply. 2.25e+06. In the year 1999, what is the difference between the Aid flow (current US$) in Burkina Faso and Aid flow (current US$) in Morocco?
Your answer should be compact. 2.45e+06. In the year 2000, what is the difference between the Aid flow (current US$) in Middle East & North Africa (all income levels) and Aid flow (current US$) in Burkina Faso?
Your answer should be very brief. 4.04e+07. In the year 2000, what is the difference between the Aid flow (current US$) of Middle East & North Africa (all income levels) and Aid flow (current US$) of Chile?
Your answer should be compact. 4.31e+07. In the year 2000, what is the difference between the Aid flow (current US$) in Middle East & North Africa (all income levels) and Aid flow (current US$) in Morocco?
Your answer should be compact. 4.27e+07. In the year 2000, what is the difference between the Aid flow (current US$) of Burkina Faso and Aid flow (current US$) of Chile?
Your response must be concise. 2.65e+06. In the year 2000, what is the difference between the Aid flow (current US$) of Burkina Faso and Aid flow (current US$) of Morocco?
Your response must be concise. 2.26e+06. In the year 2000, what is the difference between the Aid flow (current US$) of Chile and Aid flow (current US$) of Morocco?
Provide a short and direct response. -3.90e+05. In the year 2001, what is the difference between the Aid flow (current US$) in Middle East & North Africa (all income levels) and Aid flow (current US$) in Burkina Faso?
Make the answer very short. 3.06e+07. In the year 2001, what is the difference between the Aid flow (current US$) in Middle East & North Africa (all income levels) and Aid flow (current US$) in Chile?
Keep it short and to the point. 3.32e+07. In the year 2001, what is the difference between the Aid flow (current US$) in Middle East & North Africa (all income levels) and Aid flow (current US$) in Morocco?
Offer a terse response. 3.30e+07. In the year 2001, what is the difference between the Aid flow (current US$) of Burkina Faso and Aid flow (current US$) of Chile?
Give a very brief answer. 2.66e+06. In the year 2001, what is the difference between the Aid flow (current US$) in Burkina Faso and Aid flow (current US$) in Morocco?
Make the answer very short. 2.47e+06. In the year 2001, what is the difference between the Aid flow (current US$) of Chile and Aid flow (current US$) of Morocco?
Offer a very short reply. -1.90e+05. In the year 2002, what is the difference between the Aid flow (current US$) in Middle East & North Africa (all income levels) and Aid flow (current US$) in Burkina Faso?
Provide a succinct answer. 2.59e+07. In the year 2002, what is the difference between the Aid flow (current US$) in Middle East & North Africa (all income levels) and Aid flow (current US$) in Chile?
Your response must be concise. 3.38e+07. In the year 2002, what is the difference between the Aid flow (current US$) of Middle East & North Africa (all income levels) and Aid flow (current US$) of Morocco?
Offer a terse response. 3.35e+07. In the year 2002, what is the difference between the Aid flow (current US$) in Burkina Faso and Aid flow (current US$) in Chile?
Give a very brief answer. 7.85e+06. In the year 2002, what is the difference between the Aid flow (current US$) of Burkina Faso and Aid flow (current US$) of Morocco?
Make the answer very short. 7.54e+06. In the year 2002, what is the difference between the Aid flow (current US$) of Chile and Aid flow (current US$) of Morocco?
Offer a terse response. -3.10e+05. In the year 2003, what is the difference between the Aid flow (current US$) of Middle East & North Africa (all income levels) and Aid flow (current US$) of Burkina Faso?
Make the answer very short. 3.22e+07. In the year 2003, what is the difference between the Aid flow (current US$) in Middle East & North Africa (all income levels) and Aid flow (current US$) in Chile?
Ensure brevity in your answer.  3.46e+07. In the year 2003, what is the difference between the Aid flow (current US$) of Middle East & North Africa (all income levels) and Aid flow (current US$) of Morocco?
Keep it short and to the point. 3.44e+07. In the year 2003, what is the difference between the Aid flow (current US$) of Burkina Faso and Aid flow (current US$) of Chile?
Your answer should be compact. 2.37e+06. In the year 2003, what is the difference between the Aid flow (current US$) in Burkina Faso and Aid flow (current US$) in Morocco?
Give a very brief answer. 2.23e+06. What is the ratio of the Aid flow (current US$) in Middle East & North Africa (all income levels) in 1996 to that in 1997?
Your answer should be very brief. 1.11. What is the ratio of the Aid flow (current US$) of Burkina Faso in 1996 to that in 1997?
Make the answer very short. 2.45. What is the ratio of the Aid flow (current US$) in Chile in 1996 to that in 1997?
Provide a short and direct response. 6.04. What is the ratio of the Aid flow (current US$) of Morocco in 1996 to that in 1997?
Make the answer very short. 0.84. What is the ratio of the Aid flow (current US$) in Middle East & North Africa (all income levels) in 1996 to that in 1998?
Provide a succinct answer. 1.05. What is the ratio of the Aid flow (current US$) in Burkina Faso in 1996 to that in 1998?
Your answer should be compact. 1.29. What is the ratio of the Aid flow (current US$) of Chile in 1996 to that in 1998?
Make the answer very short. 6.04. What is the ratio of the Aid flow (current US$) in Morocco in 1996 to that in 1998?
Make the answer very short. 0.44. What is the ratio of the Aid flow (current US$) of Burkina Faso in 1996 to that in 1999?
Offer a terse response. 1.44. What is the ratio of the Aid flow (current US$) of Chile in 1996 to that in 1999?
Your response must be concise. 2.13. What is the ratio of the Aid flow (current US$) of Morocco in 1996 to that in 1999?
Keep it short and to the point. 1.14. What is the ratio of the Aid flow (current US$) of Middle East & North Africa (all income levels) in 1996 to that in 2000?
Give a very brief answer. 1.08. What is the ratio of the Aid flow (current US$) of Burkina Faso in 1996 to that in 2000?
Your answer should be very brief. 1.42. What is the ratio of the Aid flow (current US$) in Chile in 1996 to that in 2000?
Give a very brief answer. 4.44. What is the ratio of the Aid flow (current US$) in Morocco in 1996 to that in 2000?
Make the answer very short. 0.79. What is the ratio of the Aid flow (current US$) of Middle East & North Africa (all income levels) in 1996 to that in 2001?
Make the answer very short. 1.39. What is the ratio of the Aid flow (current US$) of Burkina Faso in 1996 to that in 2001?
Give a very brief answer. 1.44. What is the ratio of the Aid flow (current US$) in Chile in 1996 to that in 2001?
Ensure brevity in your answer.  5.21. What is the ratio of the Aid flow (current US$) of Morocco in 1996 to that in 2001?
Your answer should be compact. 1.21. What is the ratio of the Aid flow (current US$) in Middle East & North Africa (all income levels) in 1996 to that in 2002?
Give a very brief answer. 1.38. What is the ratio of the Aid flow (current US$) in Burkina Faso in 1996 to that in 2002?
Your answer should be compact. 0.53. What is the ratio of the Aid flow (current US$) in Chile in 1996 to that in 2002?
Offer a very short reply. 9.44. What is the ratio of the Aid flow (current US$) of Morocco in 1996 to that in 2002?
Give a very brief answer. 1.23. What is the ratio of the Aid flow (current US$) in Middle East & North Africa (all income levels) in 1996 to that in 2003?
Ensure brevity in your answer.  1.34. What is the ratio of the Aid flow (current US$) in Burkina Faso in 1996 to that in 2003?
Provide a succinct answer. 1.67. What is the ratio of the Aid flow (current US$) in Chile in 1996 to that in 2003?
Your answer should be very brief. 8.39. What is the ratio of the Aid flow (current US$) in Morocco in 1996 to that in 2003?
Your response must be concise. 1.81. What is the ratio of the Aid flow (current US$) of Middle East & North Africa (all income levels) in 1997 to that in 1998?
Provide a short and direct response. 0.95. What is the ratio of the Aid flow (current US$) of Burkina Faso in 1997 to that in 1998?
Your answer should be very brief. 0.53. What is the ratio of the Aid flow (current US$) in Chile in 1997 to that in 1998?
Offer a very short reply. 1. What is the ratio of the Aid flow (current US$) in Morocco in 1997 to that in 1998?
Give a very brief answer. 0.52. What is the ratio of the Aid flow (current US$) in Middle East & North Africa (all income levels) in 1997 to that in 1999?
Your response must be concise. 0.9. What is the ratio of the Aid flow (current US$) in Burkina Faso in 1997 to that in 1999?
Keep it short and to the point. 0.59. What is the ratio of the Aid flow (current US$) in Chile in 1997 to that in 1999?
Provide a succinct answer. 0.35. What is the ratio of the Aid flow (current US$) in Morocco in 1997 to that in 1999?
Provide a succinct answer. 1.35. What is the ratio of the Aid flow (current US$) of Middle East & North Africa (all income levels) in 1997 to that in 2000?
Provide a succinct answer. 0.97. What is the ratio of the Aid flow (current US$) in Burkina Faso in 1997 to that in 2000?
Give a very brief answer. 0.58. What is the ratio of the Aid flow (current US$) of Chile in 1997 to that in 2000?
Ensure brevity in your answer.  0.74. What is the ratio of the Aid flow (current US$) of Morocco in 1997 to that in 2000?
Your response must be concise. 0.95. What is the ratio of the Aid flow (current US$) of Middle East & North Africa (all income levels) in 1997 to that in 2001?
Your response must be concise. 1.26. What is the ratio of the Aid flow (current US$) of Burkina Faso in 1997 to that in 2001?
Make the answer very short. 0.59. What is the ratio of the Aid flow (current US$) in Chile in 1997 to that in 2001?
Ensure brevity in your answer.  0.86. What is the ratio of the Aid flow (current US$) of Morocco in 1997 to that in 2001?
Make the answer very short. 1.44. What is the ratio of the Aid flow (current US$) of Middle East & North Africa (all income levels) in 1997 to that in 2002?
Your answer should be compact. 1.24. What is the ratio of the Aid flow (current US$) of Burkina Faso in 1997 to that in 2002?
Provide a succinct answer. 0.22. What is the ratio of the Aid flow (current US$) of Chile in 1997 to that in 2002?
Provide a short and direct response. 1.56. What is the ratio of the Aid flow (current US$) in Morocco in 1997 to that in 2002?
Provide a short and direct response. 1.47. What is the ratio of the Aid flow (current US$) in Middle East & North Africa (all income levels) in 1997 to that in 2003?
Keep it short and to the point. 1.21. What is the ratio of the Aid flow (current US$) of Burkina Faso in 1997 to that in 2003?
Your answer should be very brief. 0.68. What is the ratio of the Aid flow (current US$) in Chile in 1997 to that in 2003?
Give a very brief answer. 1.39. What is the ratio of the Aid flow (current US$) in Morocco in 1997 to that in 2003?
Keep it short and to the point. 2.16. What is the ratio of the Aid flow (current US$) in Middle East & North Africa (all income levels) in 1998 to that in 1999?
Make the answer very short. 0.95. What is the ratio of the Aid flow (current US$) of Burkina Faso in 1998 to that in 1999?
Keep it short and to the point. 1.11. What is the ratio of the Aid flow (current US$) of Chile in 1998 to that in 1999?
Your answer should be very brief. 0.35. What is the ratio of the Aid flow (current US$) of Morocco in 1998 to that in 1999?
Your answer should be compact. 2.61. What is the ratio of the Aid flow (current US$) in Middle East & North Africa (all income levels) in 1998 to that in 2000?
Your answer should be very brief. 1.03. What is the ratio of the Aid flow (current US$) in Burkina Faso in 1998 to that in 2000?
Provide a succinct answer. 1.1. What is the ratio of the Aid flow (current US$) in Chile in 1998 to that in 2000?
Provide a short and direct response. 0.74. What is the ratio of the Aid flow (current US$) of Morocco in 1998 to that in 2000?
Provide a short and direct response. 1.82. What is the ratio of the Aid flow (current US$) in Middle East & North Africa (all income levels) in 1998 to that in 2001?
Your response must be concise. 1.33. What is the ratio of the Aid flow (current US$) in Burkina Faso in 1998 to that in 2001?
Ensure brevity in your answer.  1.12. What is the ratio of the Aid flow (current US$) in Chile in 1998 to that in 2001?
Provide a succinct answer. 0.86. What is the ratio of the Aid flow (current US$) in Morocco in 1998 to that in 2001?
Make the answer very short. 2.77. What is the ratio of the Aid flow (current US$) in Middle East & North Africa (all income levels) in 1998 to that in 2002?
Your response must be concise. 1.31. What is the ratio of the Aid flow (current US$) in Burkina Faso in 1998 to that in 2002?
Your answer should be compact. 0.41. What is the ratio of the Aid flow (current US$) of Chile in 1998 to that in 2002?
Your answer should be compact. 1.56. What is the ratio of the Aid flow (current US$) in Morocco in 1998 to that in 2002?
Your answer should be compact. 2.83. What is the ratio of the Aid flow (current US$) of Middle East & North Africa (all income levels) in 1998 to that in 2003?
Offer a very short reply. 1.28. What is the ratio of the Aid flow (current US$) in Burkina Faso in 1998 to that in 2003?
Offer a very short reply. 1.29. What is the ratio of the Aid flow (current US$) in Chile in 1998 to that in 2003?
Offer a terse response. 1.39. What is the ratio of the Aid flow (current US$) of Morocco in 1998 to that in 2003?
Offer a terse response. 4.16. What is the ratio of the Aid flow (current US$) of Middle East & North Africa (all income levels) in 1999 to that in 2000?
Provide a short and direct response. 1.08. What is the ratio of the Aid flow (current US$) of Burkina Faso in 1999 to that in 2000?
Offer a terse response. 0.99. What is the ratio of the Aid flow (current US$) of Chile in 1999 to that in 2000?
Your answer should be very brief. 2.09. What is the ratio of the Aid flow (current US$) in Morocco in 1999 to that in 2000?
Provide a short and direct response. 0.7. What is the ratio of the Aid flow (current US$) in Middle East & North Africa (all income levels) in 1999 to that in 2001?
Your answer should be compact. 1.39. What is the ratio of the Aid flow (current US$) of Burkina Faso in 1999 to that in 2001?
Keep it short and to the point. 1. What is the ratio of the Aid flow (current US$) in Chile in 1999 to that in 2001?
Your answer should be very brief. 2.45. What is the ratio of the Aid flow (current US$) of Morocco in 1999 to that in 2001?
Provide a succinct answer. 1.06. What is the ratio of the Aid flow (current US$) of Middle East & North Africa (all income levels) in 1999 to that in 2002?
Provide a short and direct response. 1.38. What is the ratio of the Aid flow (current US$) in Burkina Faso in 1999 to that in 2002?
Offer a very short reply. 0.37. What is the ratio of the Aid flow (current US$) in Chile in 1999 to that in 2002?
Provide a short and direct response. 4.44. What is the ratio of the Aid flow (current US$) of Morocco in 1999 to that in 2002?
Offer a very short reply. 1.09. What is the ratio of the Aid flow (current US$) in Middle East & North Africa (all income levels) in 1999 to that in 2003?
Give a very brief answer. 1.34. What is the ratio of the Aid flow (current US$) of Burkina Faso in 1999 to that in 2003?
Provide a short and direct response. 1.16. What is the ratio of the Aid flow (current US$) in Chile in 1999 to that in 2003?
Provide a short and direct response. 3.94. What is the ratio of the Aid flow (current US$) of Morocco in 1999 to that in 2003?
Keep it short and to the point. 1.59. What is the ratio of the Aid flow (current US$) in Middle East & North Africa (all income levels) in 2000 to that in 2001?
Give a very brief answer. 1.3. What is the ratio of the Aid flow (current US$) of Burkina Faso in 2000 to that in 2001?
Make the answer very short. 1.01. What is the ratio of the Aid flow (current US$) in Chile in 2000 to that in 2001?
Provide a short and direct response. 1.17. What is the ratio of the Aid flow (current US$) of Morocco in 2000 to that in 2001?
Make the answer very short. 1.52. What is the ratio of the Aid flow (current US$) in Middle East & North Africa (all income levels) in 2000 to that in 2002?
Ensure brevity in your answer.  1.28. What is the ratio of the Aid flow (current US$) in Burkina Faso in 2000 to that in 2002?
Make the answer very short. 0.37. What is the ratio of the Aid flow (current US$) in Chile in 2000 to that in 2002?
Ensure brevity in your answer.  2.12. What is the ratio of the Aid flow (current US$) in Morocco in 2000 to that in 2002?
Keep it short and to the point. 1.55. What is the ratio of the Aid flow (current US$) in Middle East & North Africa (all income levels) in 2000 to that in 2003?
Make the answer very short. 1.25. What is the ratio of the Aid flow (current US$) of Burkina Faso in 2000 to that in 2003?
Provide a short and direct response. 1.17. What is the ratio of the Aid flow (current US$) in Chile in 2000 to that in 2003?
Your answer should be very brief. 1.89. What is the ratio of the Aid flow (current US$) of Morocco in 2000 to that in 2003?
Your answer should be very brief. 2.28. What is the ratio of the Aid flow (current US$) of Middle East & North Africa (all income levels) in 2001 to that in 2002?
Your response must be concise. 0.99. What is the ratio of the Aid flow (current US$) of Burkina Faso in 2001 to that in 2002?
Offer a very short reply. 0.37. What is the ratio of the Aid flow (current US$) in Chile in 2001 to that in 2002?
Your answer should be compact. 1.81. What is the ratio of the Aid flow (current US$) of Morocco in 2001 to that in 2002?
Provide a short and direct response. 1.02. What is the ratio of the Aid flow (current US$) in Burkina Faso in 2001 to that in 2003?
Make the answer very short. 1.16. What is the ratio of the Aid flow (current US$) in Chile in 2001 to that in 2003?
Give a very brief answer. 1.61. What is the ratio of the Aid flow (current US$) of Morocco in 2001 to that in 2003?
Provide a short and direct response. 1.5. What is the ratio of the Aid flow (current US$) of Middle East & North Africa (all income levels) in 2002 to that in 2003?
Provide a short and direct response. 0.98. What is the ratio of the Aid flow (current US$) in Burkina Faso in 2002 to that in 2003?
Give a very brief answer. 3.14. What is the ratio of the Aid flow (current US$) of Chile in 2002 to that in 2003?
Give a very brief answer. 0.89. What is the ratio of the Aid flow (current US$) in Morocco in 2002 to that in 2003?
Make the answer very short. 1.47. What is the difference between the highest and the second highest Aid flow (current US$) in Burkina Faso?
Make the answer very short. 3.75e+06. What is the difference between the highest and the second highest Aid flow (current US$) in Chile?
Ensure brevity in your answer.  8.00e+05. What is the difference between the highest and the second highest Aid flow (current US$) of Morocco?
Your answer should be very brief. 6.00e+05. What is the difference between the highest and the lowest Aid flow (current US$) of Middle East & North Africa (all income levels)?
Give a very brief answer. 1.32e+07. What is the difference between the highest and the lowest Aid flow (current US$) in Burkina Faso?
Ensure brevity in your answer.  6.27e+06. What is the difference between the highest and the lowest Aid flow (current US$) of Chile?
Offer a terse response. 1.35e+06. What is the difference between the highest and the lowest Aid flow (current US$) of Morocco?
Provide a succinct answer. 1.01e+06. 